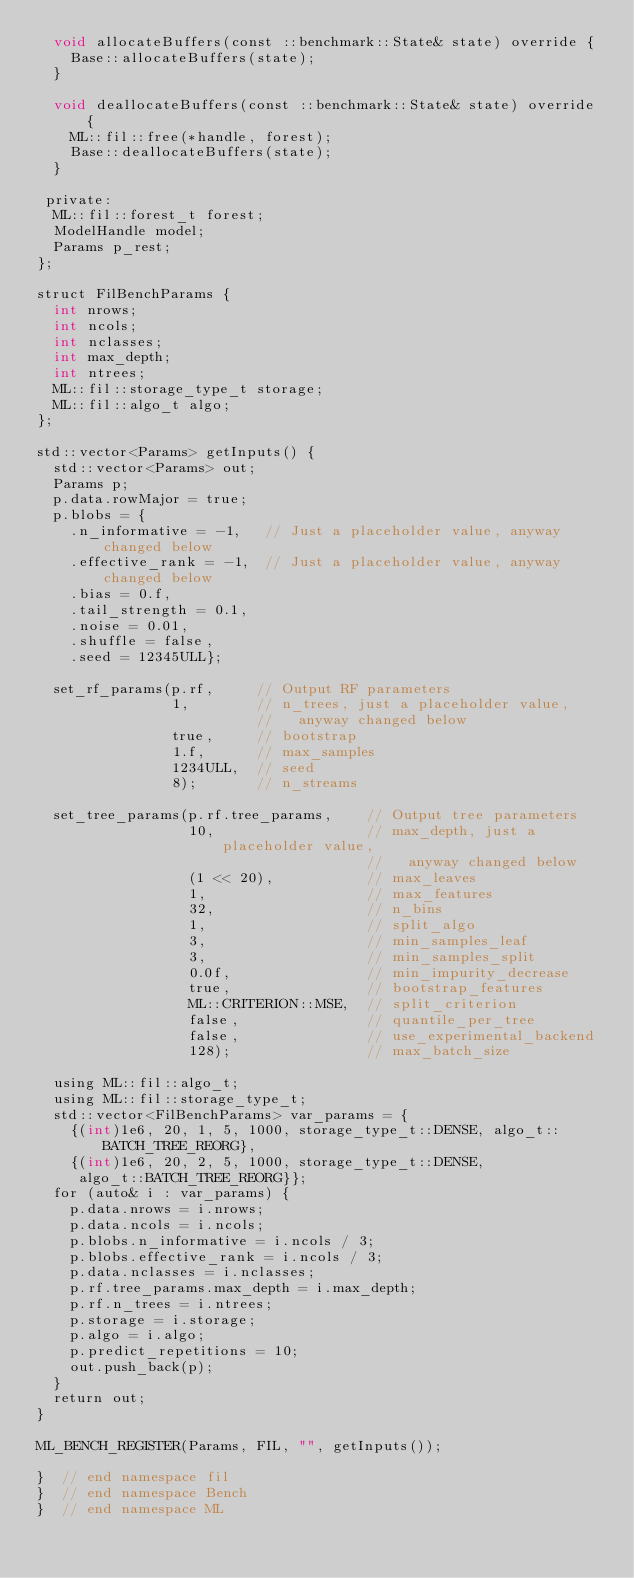<code> <loc_0><loc_0><loc_500><loc_500><_Cuda_>  void allocateBuffers(const ::benchmark::State& state) override {
    Base::allocateBuffers(state);
  }

  void deallocateBuffers(const ::benchmark::State& state) override {
    ML::fil::free(*handle, forest);
    Base::deallocateBuffers(state);
  }

 private:
  ML::fil::forest_t forest;
  ModelHandle model;
  Params p_rest;
};

struct FilBenchParams {
  int nrows;
  int ncols;
  int nclasses;
  int max_depth;
  int ntrees;
  ML::fil::storage_type_t storage;
  ML::fil::algo_t algo;
};

std::vector<Params> getInputs() {
  std::vector<Params> out;
  Params p;
  p.data.rowMajor = true;
  p.blobs = {
    .n_informative = -1,   // Just a placeholder value, anyway changed below
    .effective_rank = -1,  // Just a placeholder value, anyway changed below
    .bias = 0.f,
    .tail_strength = 0.1,
    .noise = 0.01,
    .shuffle = false,
    .seed = 12345ULL};

  set_rf_params(p.rf,     // Output RF parameters
                1,        // n_trees, just a placeholder value,
                          //   anyway changed below
                true,     // bootstrap
                1.f,      // max_samples
                1234ULL,  // seed
                8);       // n_streams

  set_tree_params(p.rf.tree_params,    // Output tree parameters
                  10,                  // max_depth, just a placeholder value,
                                       //   anyway changed below
                  (1 << 20),           // max_leaves
                  1,                   // max_features
                  32,                  // n_bins
                  1,                   // split_algo
                  3,                   // min_samples_leaf
                  3,                   // min_samples_split
                  0.0f,                // min_impurity_decrease
                  true,                // bootstrap_features
                  ML::CRITERION::MSE,  // split_criterion
                  false,               // quantile_per_tree
                  false,               // use_experimental_backend
                  128);                // max_batch_size

  using ML::fil::algo_t;
  using ML::fil::storage_type_t;
  std::vector<FilBenchParams> var_params = {
    {(int)1e6, 20, 1, 5, 1000, storage_type_t::DENSE, algo_t::BATCH_TREE_REORG},
    {(int)1e6, 20, 2, 5, 1000, storage_type_t::DENSE,
     algo_t::BATCH_TREE_REORG}};
  for (auto& i : var_params) {
    p.data.nrows = i.nrows;
    p.data.ncols = i.ncols;
    p.blobs.n_informative = i.ncols / 3;
    p.blobs.effective_rank = i.ncols / 3;
    p.data.nclasses = i.nclasses;
    p.rf.tree_params.max_depth = i.max_depth;
    p.rf.n_trees = i.ntrees;
    p.storage = i.storage;
    p.algo = i.algo;
    p.predict_repetitions = 10;
    out.push_back(p);
  }
  return out;
}

ML_BENCH_REGISTER(Params, FIL, "", getInputs());

}  // end namespace fil
}  // end namespace Bench
}  // end namespace ML
</code> 